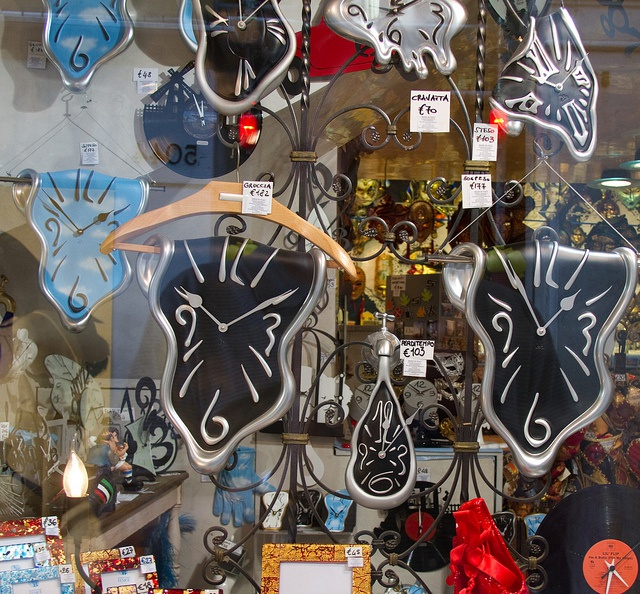Describe the objects in this image and their specific colors. I can see clock in gray, black, darkgray, and tan tones, clock in gray, black, and darkgray tones, clock in gray, darkgray, and lightblue tones, clock in gray, white, and darkgray tones, and clock in gray, darkblue, black, and navy tones in this image. 